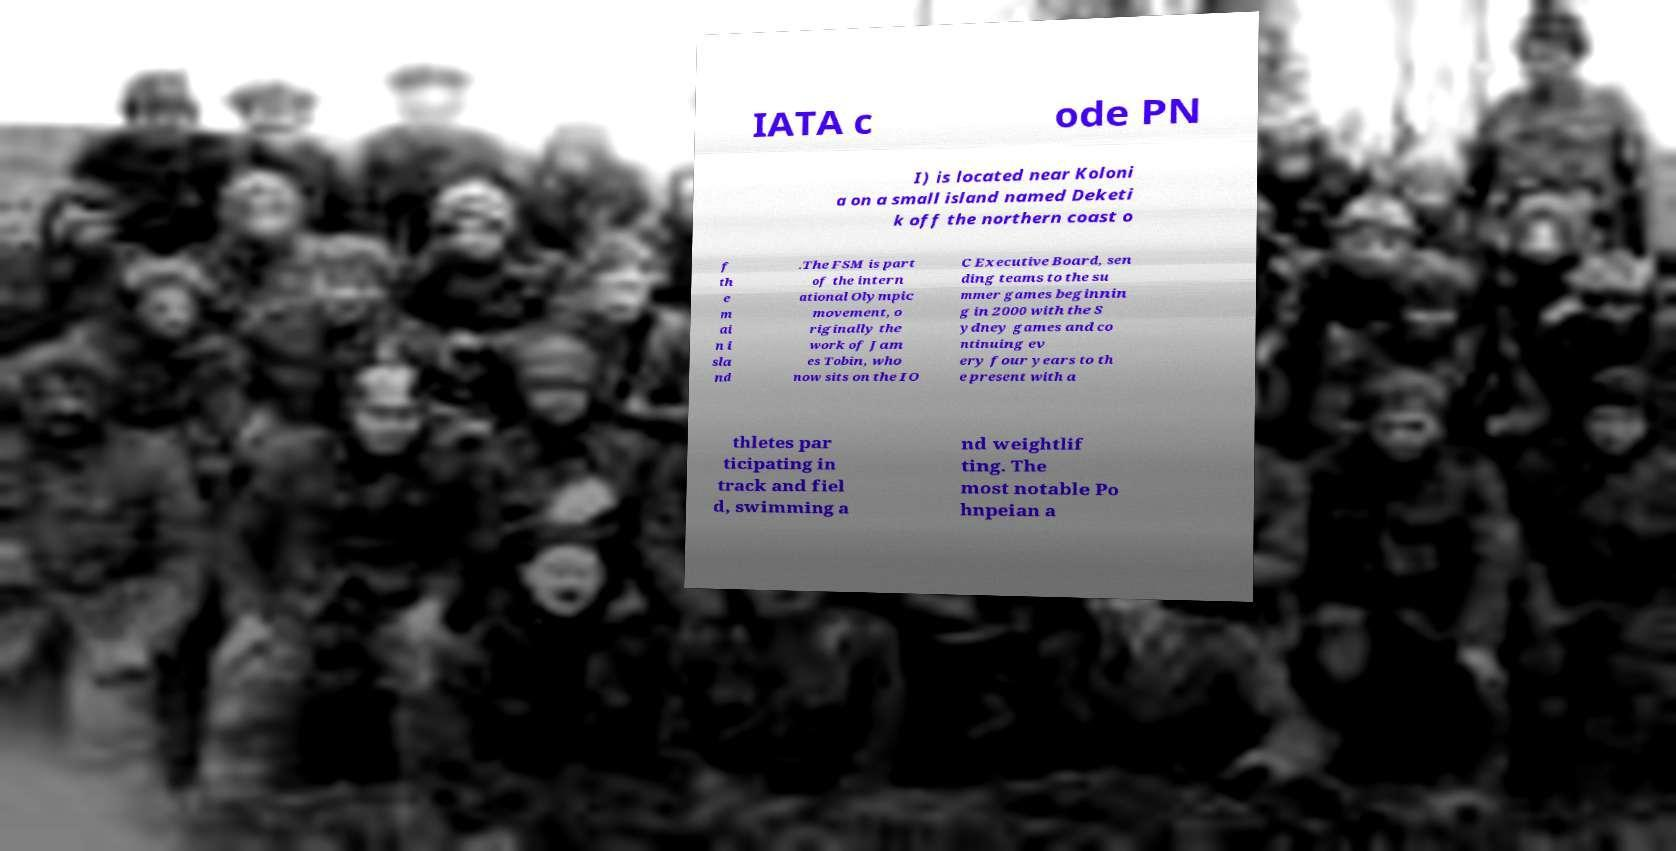Please read and relay the text visible in this image. What does it say? IATA c ode PN I) is located near Koloni a on a small island named Deketi k off the northern coast o f th e m ai n i sla nd .The FSM is part of the intern ational Olympic movement, o riginally the work of Jam es Tobin, who now sits on the IO C Executive Board, sen ding teams to the su mmer games beginnin g in 2000 with the S ydney games and co ntinuing ev ery four years to th e present with a thletes par ticipating in track and fiel d, swimming a nd weightlif ting. The most notable Po hnpeian a 